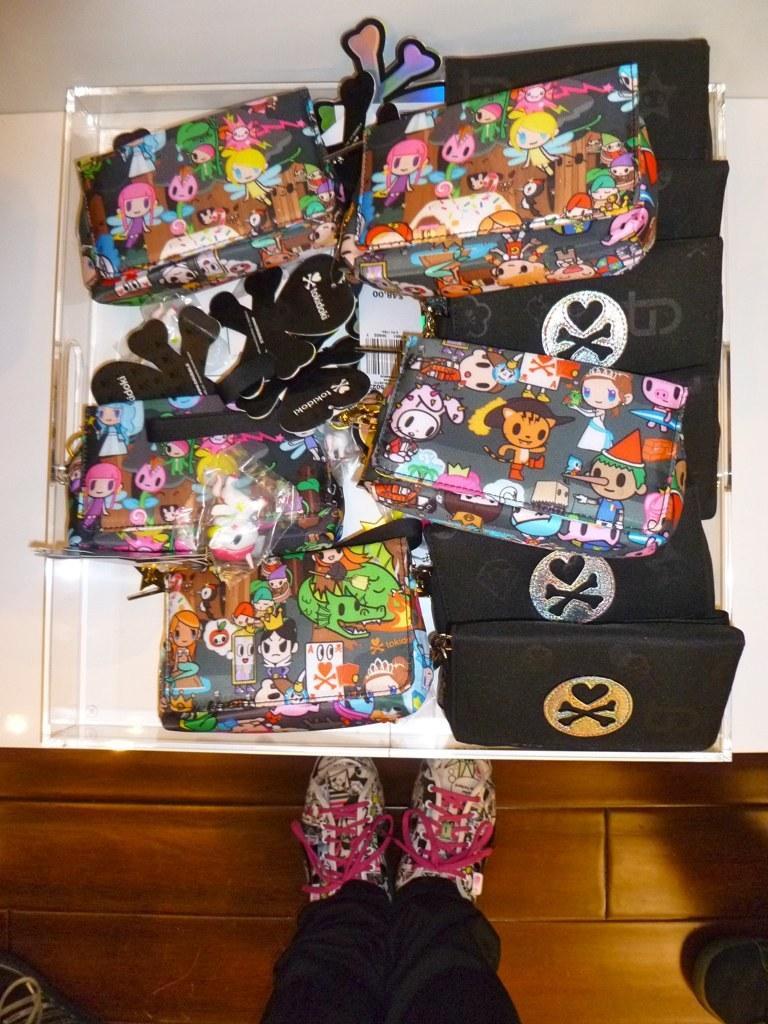Describe this image in one or two sentences. In this picture we can able to see few wallets. Some wallets are in cartoon design and some wallets are in black color. There is a wood floor. A man leg with a shoe. The shoes are in white color and pink lace. The wallets are kept in a container. 